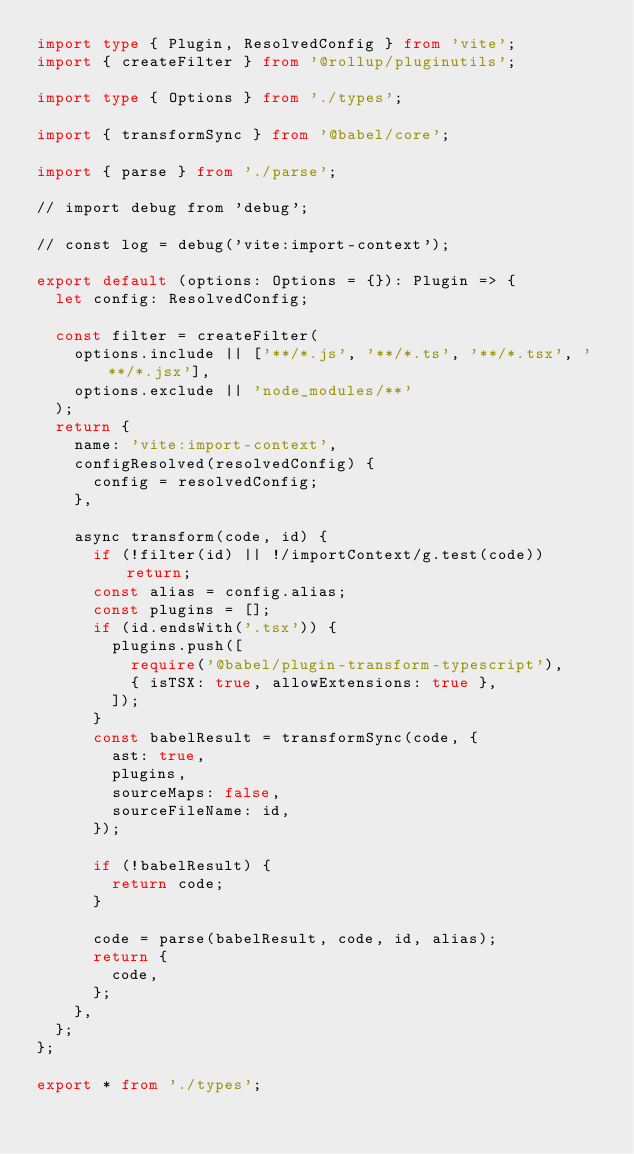Convert code to text. <code><loc_0><loc_0><loc_500><loc_500><_TypeScript_>import type { Plugin, ResolvedConfig } from 'vite';
import { createFilter } from '@rollup/pluginutils';

import type { Options } from './types';

import { transformSync } from '@babel/core';

import { parse } from './parse';

// import debug from 'debug';

// const log = debug('vite:import-context');

export default (options: Options = {}): Plugin => {
  let config: ResolvedConfig;

  const filter = createFilter(
    options.include || ['**/*.js', '**/*.ts', '**/*.tsx', '**/*.jsx'],
    options.exclude || 'node_modules/**'
  );
  return {
    name: 'vite:import-context',
    configResolved(resolvedConfig) {
      config = resolvedConfig;
    },

    async transform(code, id) {
      if (!filter(id) || !/importContext/g.test(code)) return;
      const alias = config.alias;
      const plugins = [];
      if (id.endsWith('.tsx')) {
        plugins.push([
          require('@babel/plugin-transform-typescript'),
          { isTSX: true, allowExtensions: true },
        ]);
      }
      const babelResult = transformSync(code, {
        ast: true,
        plugins,
        sourceMaps: false,
        sourceFileName: id,
      });

      if (!babelResult) {
        return code;
      }

      code = parse(babelResult, code, id, alias);
      return {
        code,
      };
    },
  };
};

export * from './types';
</code> 